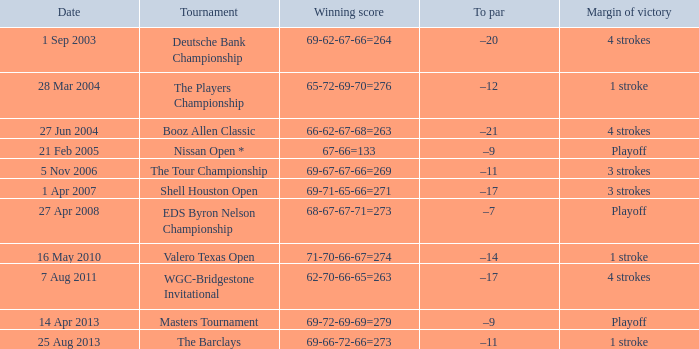I'm looking to parse the entire table for insights. Could you assist me with that? {'header': ['Date', 'Tournament', 'Winning score', 'To par', 'Margin of victory'], 'rows': [['1 Sep 2003', 'Deutsche Bank Championship', '69-62-67-66=264', '–20', '4 strokes'], ['28 Mar 2004', 'The Players Championship', '65-72-69-70=276', '–12', '1 stroke'], ['27 Jun 2004', 'Booz Allen Classic', '66-62-67-68=263', '–21', '4 strokes'], ['21 Feb 2005', 'Nissan Open *', '67-66=133', '–9', 'Playoff'], ['5 Nov 2006', 'The Tour Championship', '69-67-67-66=269', '–11', '3 strokes'], ['1 Apr 2007', 'Shell Houston Open', '69-71-65-66=271', '–17', '3 strokes'], ['27 Apr 2008', 'EDS Byron Nelson Championship', '68-67-67-71=273', '–7', 'Playoff'], ['16 May 2010', 'Valero Texas Open', '71-70-66-67=274', '–14', '1 stroke'], ['7 Aug 2011', 'WGC-Bridgestone Invitational', '62-70-66-65=263', '–17', '4 strokes'], ['14 Apr 2013', 'Masters Tournament', '69-72-69-69=279', '–9', 'Playoff'], ['25 Aug 2013', 'The Barclays', '69-66-72-66=273', '–11', '1 stroke']]} On which date is the to par equal to -12? 28 Mar 2004. 